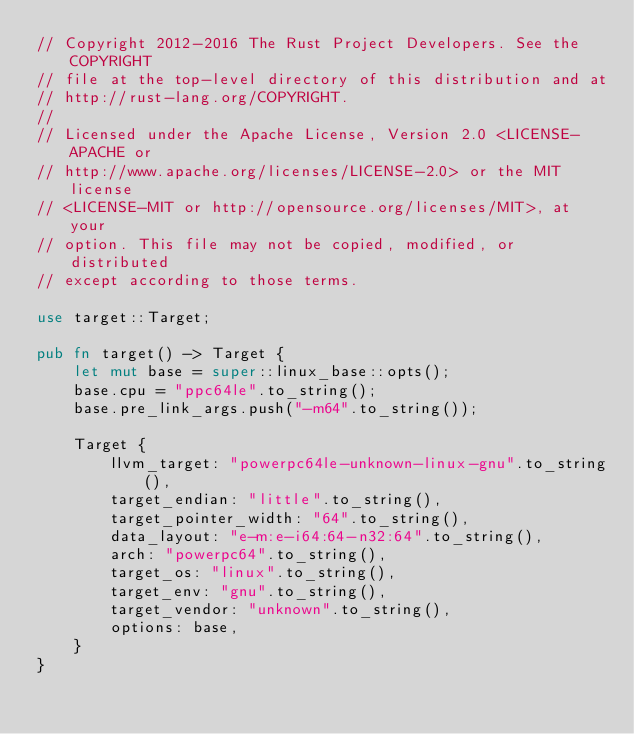Convert code to text. <code><loc_0><loc_0><loc_500><loc_500><_Rust_>// Copyright 2012-2016 The Rust Project Developers. See the COPYRIGHT
// file at the top-level directory of this distribution and at
// http://rust-lang.org/COPYRIGHT.
//
// Licensed under the Apache License, Version 2.0 <LICENSE-APACHE or
// http://www.apache.org/licenses/LICENSE-2.0> or the MIT license
// <LICENSE-MIT or http://opensource.org/licenses/MIT>, at your
// option. This file may not be copied, modified, or distributed
// except according to those terms.

use target::Target;

pub fn target() -> Target {
    let mut base = super::linux_base::opts();
    base.cpu = "ppc64le".to_string();
    base.pre_link_args.push("-m64".to_string());

    Target {
        llvm_target: "powerpc64le-unknown-linux-gnu".to_string(),
        target_endian: "little".to_string(),
        target_pointer_width: "64".to_string(),
        data_layout: "e-m:e-i64:64-n32:64".to_string(),
        arch: "powerpc64".to_string(),
        target_os: "linux".to_string(),
        target_env: "gnu".to_string(),
        target_vendor: "unknown".to_string(),
        options: base,
    }
}
</code> 